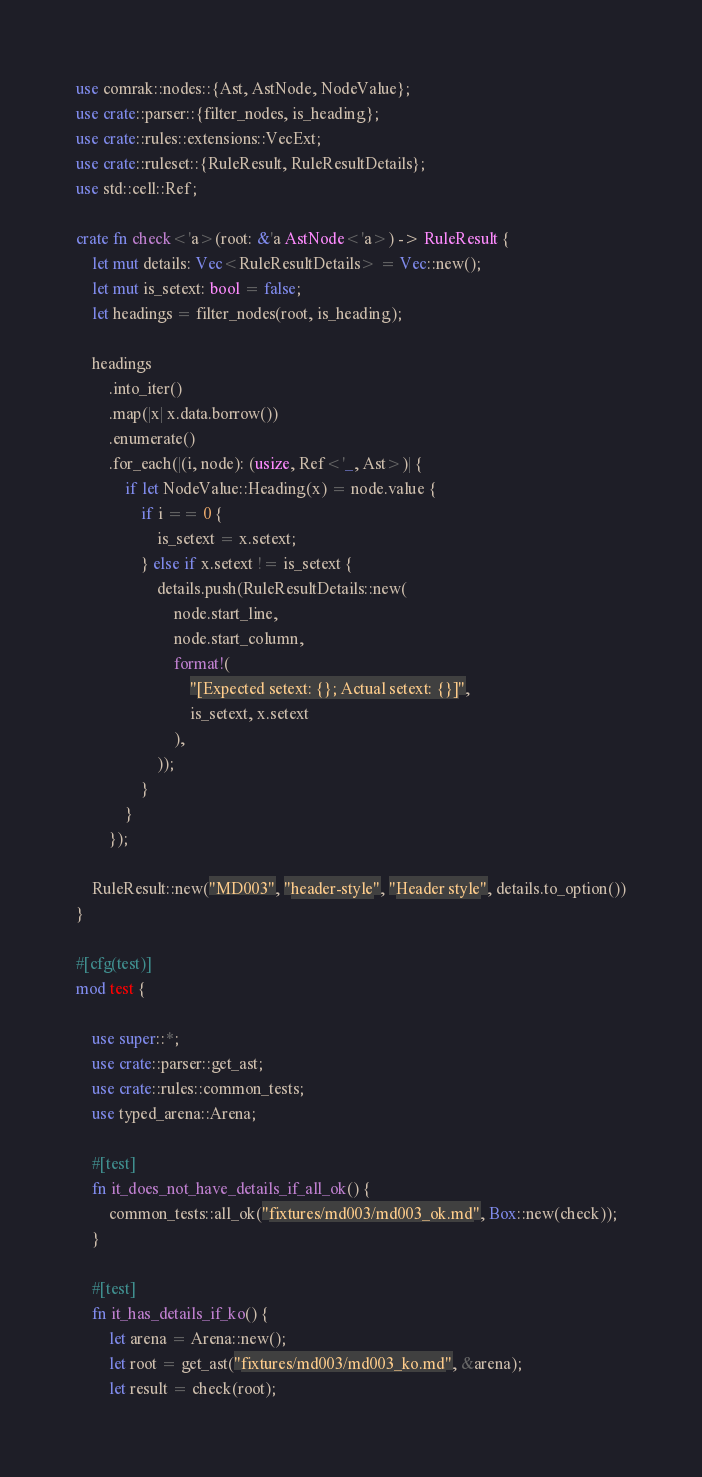Convert code to text. <code><loc_0><loc_0><loc_500><loc_500><_Rust_>use comrak::nodes::{Ast, AstNode, NodeValue};
use crate::parser::{filter_nodes, is_heading};
use crate::rules::extensions::VecExt;
use crate::ruleset::{RuleResult, RuleResultDetails};
use std::cell::Ref;

crate fn check<'a>(root: &'a AstNode<'a>) -> RuleResult {
    let mut details: Vec<RuleResultDetails> = Vec::new();
    let mut is_setext: bool = false;
    let headings = filter_nodes(root, is_heading);

    headings
        .into_iter()
        .map(|x| x.data.borrow())
        .enumerate()
        .for_each(|(i, node): (usize, Ref<'_, Ast>)| {
            if let NodeValue::Heading(x) = node.value {
                if i == 0 {
                    is_setext = x.setext;
                } else if x.setext != is_setext {
                    details.push(RuleResultDetails::new(
                        node.start_line,
                        node.start_column,
                        format!(
                            "[Expected setext: {}; Actual setext: {}]",
                            is_setext, x.setext
                        ),
                    ));
                }
            }
        });

    RuleResult::new("MD003", "header-style", "Header style", details.to_option())
}

#[cfg(test)]
mod test {

    use super::*;
    use crate::parser::get_ast;
    use crate::rules::common_tests;
    use typed_arena::Arena;

    #[test]
    fn it_does_not_have_details_if_all_ok() {
        common_tests::all_ok("fixtures/md003/md003_ok.md", Box::new(check));
    }

    #[test]
    fn it_has_details_if_ko() {
        let arena = Arena::new();
        let root = get_ast("fixtures/md003/md003_ko.md", &arena);
        let result = check(root);</code> 